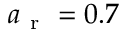Convert formula to latex. <formula><loc_0><loc_0><loc_500><loc_500>a _ { r } = 0 . 7</formula> 